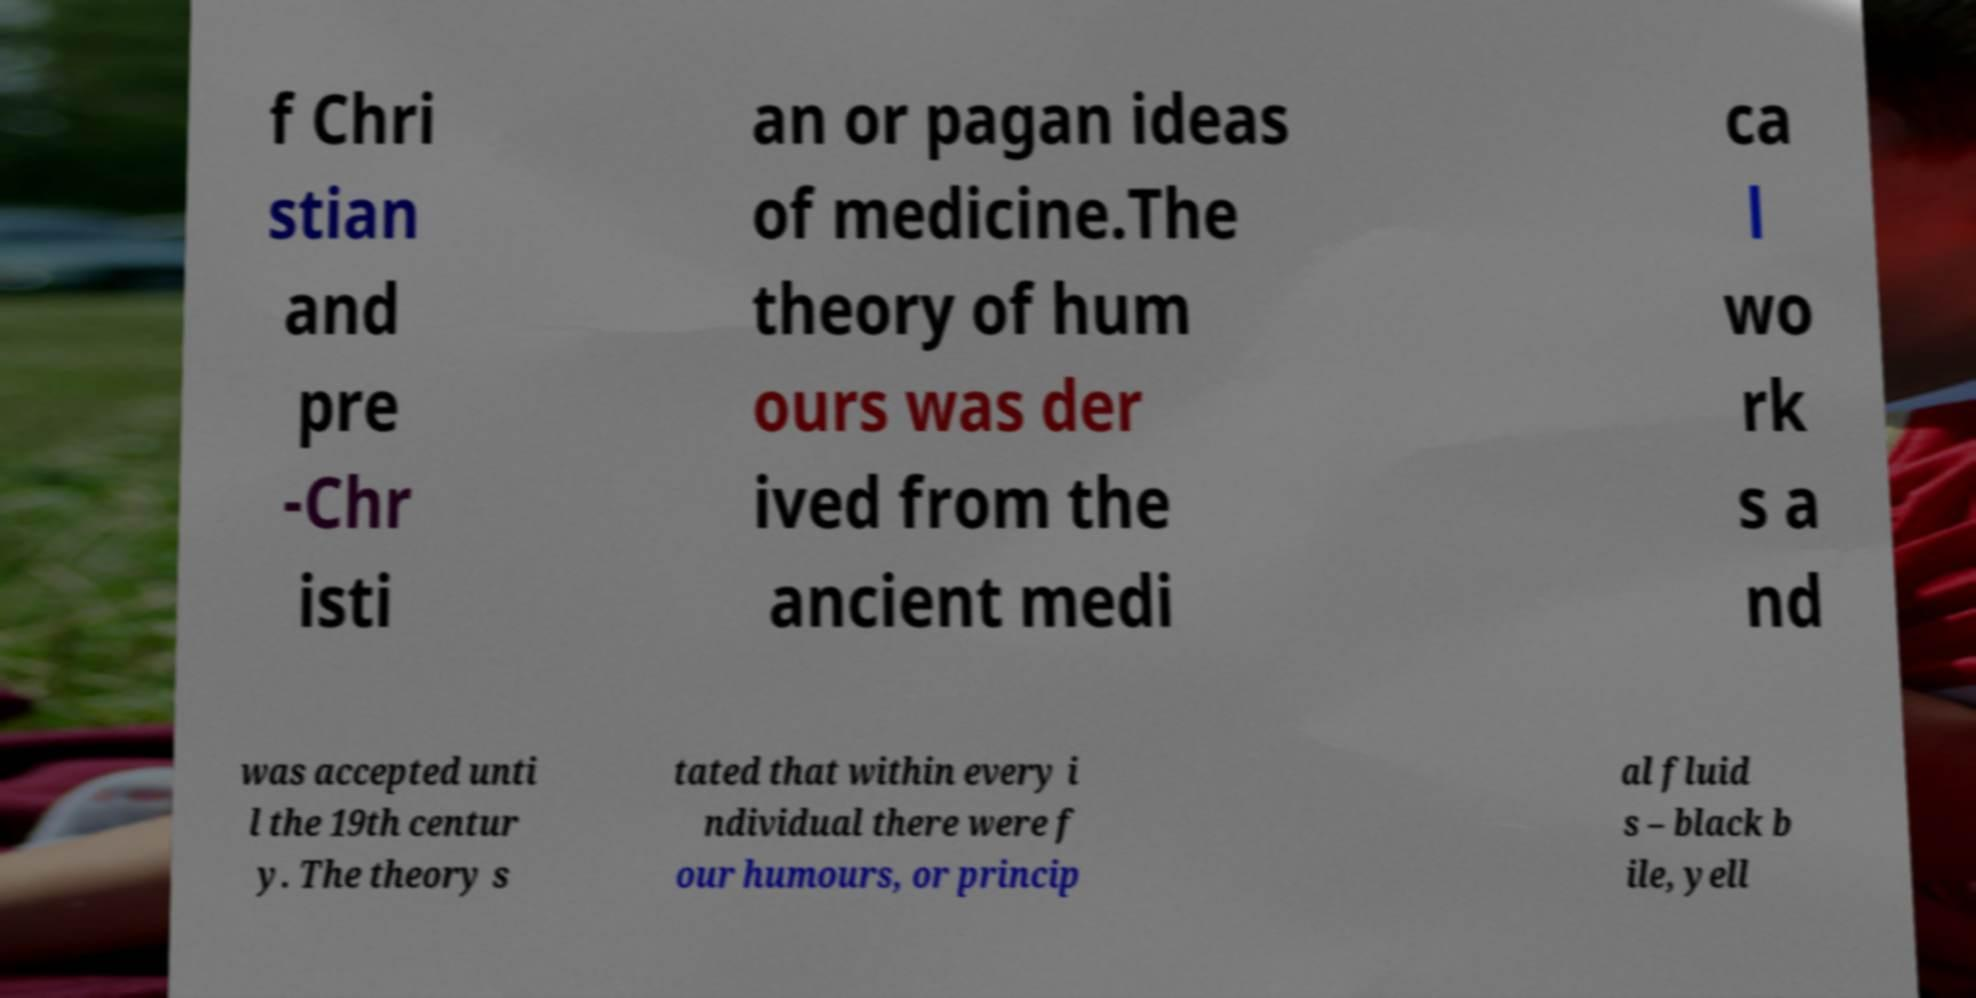I need the written content from this picture converted into text. Can you do that? f Chri stian and pre -Chr isti an or pagan ideas of medicine.The theory of hum ours was der ived from the ancient medi ca l wo rk s a nd was accepted unti l the 19th centur y. The theory s tated that within every i ndividual there were f our humours, or princip al fluid s – black b ile, yell 